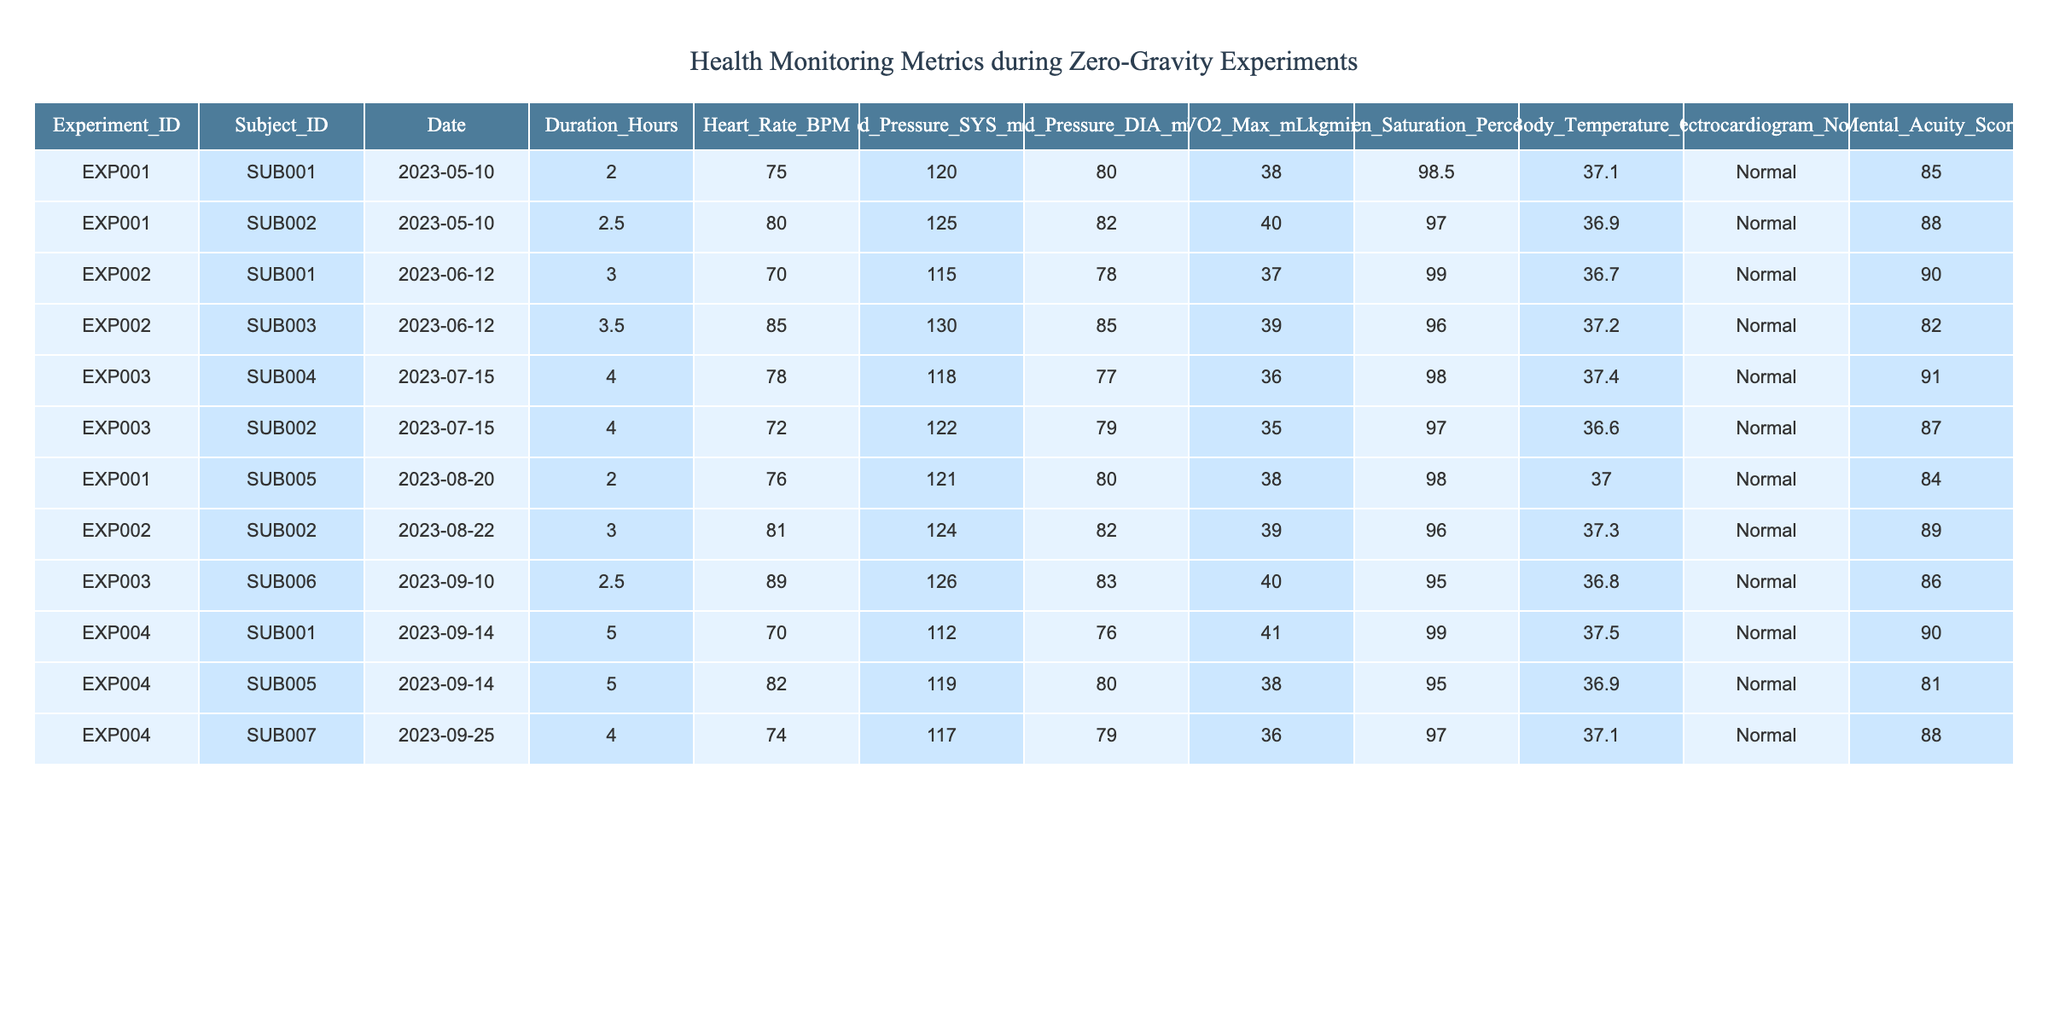What was the highest heart rate recorded during the experiments? The highest heart rate in the table is 89 BPM, recorded for Subject ID SUB006 during EXP003 on 2023-09-10.
Answer: 89 BPM What is the average blood pressure (systolic) across all experiments? To find the average systolic blood pressure, sum the systolic values (120 + 125 + 115 + 130 + 118 + 122 + 121 + 124 + 126 + 112 + 119 + 117) which equals 1436. Dividing by the number of entries (12) gives an average of 119.67 mmHg.
Answer: 119.67 mmHg Did any subjects experience an oxygen saturation level below 95%? By checking the oxygen saturation data, we see that the lowest recorded value is 95%, so no subjects experienced a level below 95%.
Answer: No Which subject had the longest duration of participation in the experiments? The longest duration recorded is 5 hours during EXP004 for both Subject ID SUB001 and SUB005.
Answer: SUB001 and SUB005 What is the median mental acuity score of all subjects who participated? The mental acuity scores are (85, 88, 90, 82, 91, 87, 84, 89, 86, 90, 81, 88), which when sorted gives (81, 82, 84, 85, 86, 87, 88, 88, 89, 90, 90, 91). Since there are 12 scores, the median is the average of the 6th and 7th values, which is (87 + 88) / 2 = 87.5.
Answer: 87.5 What is the relationship between blood pressure and heart rate in the dataset? By comparing the blood pressure and heart rate values through scatter plots or correlation calculations, we can examine their relationship. However, an initial visual assessment shows that heart rate does not consistently increase or decrease with changes in blood pressure.
Answer: No clear relationship How many experiments had duration longer than 3 hours? A review of the duration column shows that the experiments with durations longer than 3 hours are EXP002, EXP003, and EXP004, totaling 5 instances.
Answer: 5 instances Which experiment had the highest VO2 Max recorded, and who was the subject? The highest VO2 Max recorded is 41 mL/kg/min during EXP004 for Subject ID SUB001.
Answer: EXP004, SUB001 Which subject experienced a drop in oxygen saturation between the first and second experiment? By tracking Subject ID SUB002, the first experiment showed an oxygen saturation of 97% during EXP001 and dropped to 96% during EXP002, demonstrating a drop.
Answer: SUB002 Are there any recorded instances of abnormal electrocardiogram notes? Looking at the electrocardiogram notes for all entries shows that all are recorded as "Normal", which indicates there are no abnormal instances.
Answer: No What was the average body temperature recorded during the experiments? The body temperature values (37.1, 36.9, 36.7, 37.2, 37.4, 36.6, 37, 37.3, 36.8, 37.5, 36.9, 37.1) sum up to 445.2. Dividing this by 12 gives an average body temperature of 37.1°C.
Answer: 37.1°C 